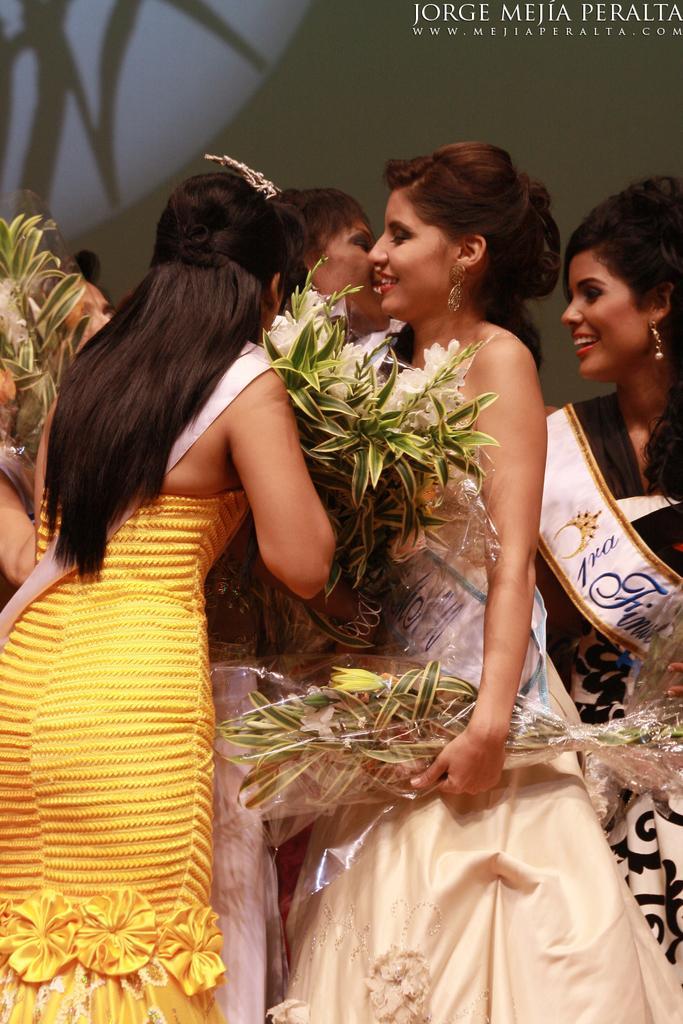Please provide a concise description of this image. In this picture there are girls in the center of the image, by holding flowers in their hands and there is a poster in the background area of the image. 